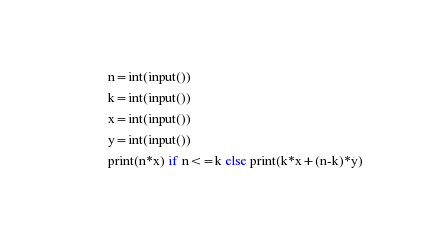Convert code to text. <code><loc_0><loc_0><loc_500><loc_500><_Python_>n=int(input())
k=int(input())
x=int(input())
y=int(input())
print(n*x) if n<=k else print(k*x+(n-k)*y)
</code> 